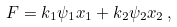<formula> <loc_0><loc_0><loc_500><loc_500>F = k _ { 1 } \psi _ { 1 } x _ { 1 } + k _ { 2 } \psi _ { 2 } x _ { 2 } \, ,</formula> 